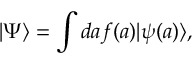Convert formula to latex. <formula><loc_0><loc_0><loc_500><loc_500>| \Psi \rangle = \int d a f ( a ) | \psi ( a ) \rangle ,</formula> 